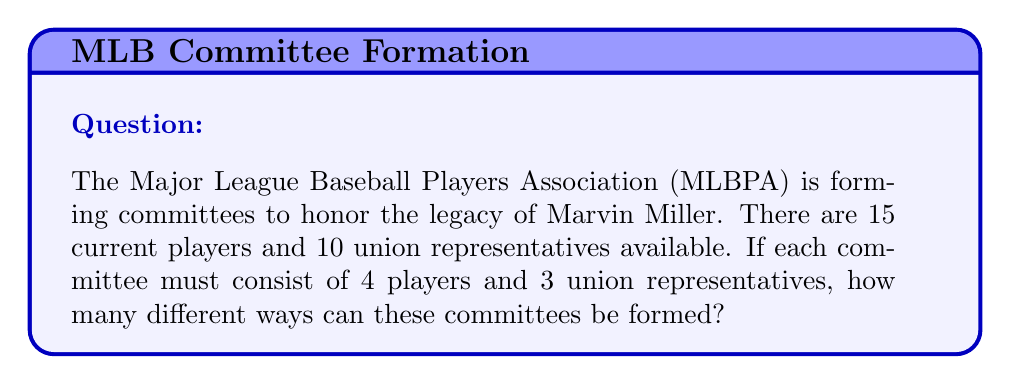What is the answer to this math problem? Let's approach this step-by-step:

1) First, we need to choose 4 players out of 15. This can be done in $\binom{15}{4}$ ways.

2) The number of ways to choose 4 players out of 15 is:

   $$\binom{15}{4} = \frac{15!}{4!(15-4)!} = \frac{15!}{4!11!} = 1365$$

3) Next, we need to choose 3 union representatives out of 10. This can be done in $\binom{10}{3}$ ways.

4) The number of ways to choose 3 representatives out of 10 is:

   $$\binom{10}{3} = \frac{10!}{3!(10-3)!} = \frac{10!}{3!7!} = 120$$

5) By the multiplication principle, the total number of ways to form the committee is the product of these two numbers:

   $$1365 \times 120 = 163,800$$

Therefore, there are 163,800 different ways to form these committees.
Answer: 163,800 